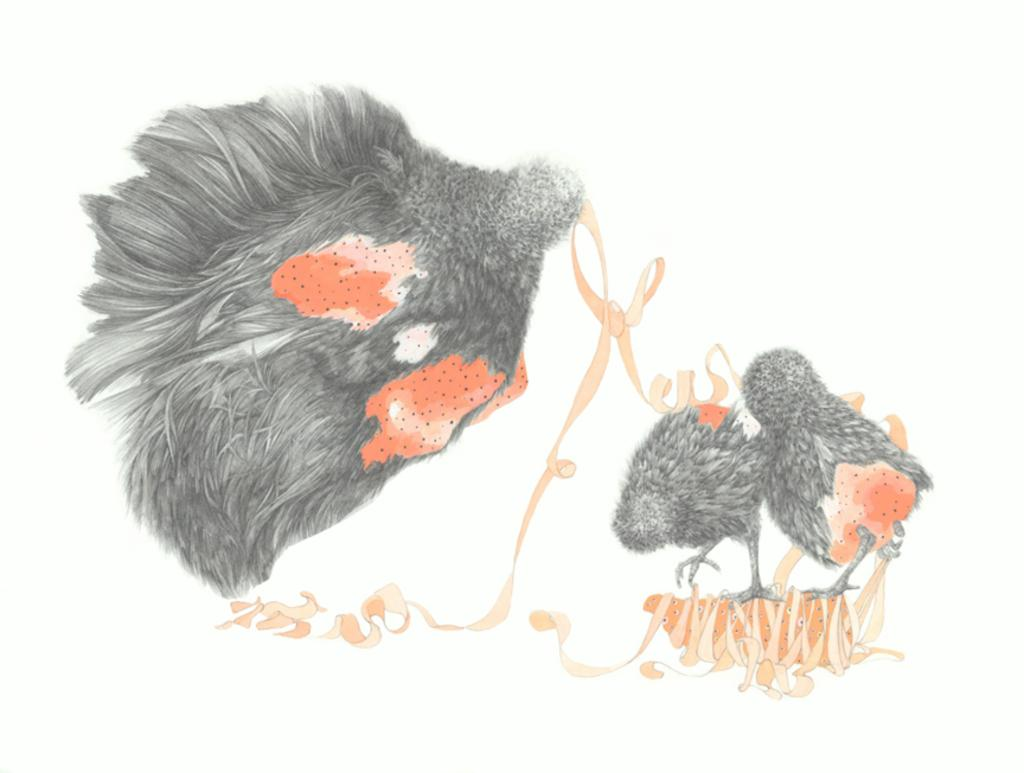What type of art is depicted in the image? The image contains art on paper. What animals are featured in the art? There is a hen and chickens in the art. What colors are the hen and chickens in the art? The hen and chickens are black and red in color. What type of seat can be seen in the image? There is no seat present in the image; it features art on paper with a hen and chickens. How many trains are visible in the image? There are no trains present in the image. 